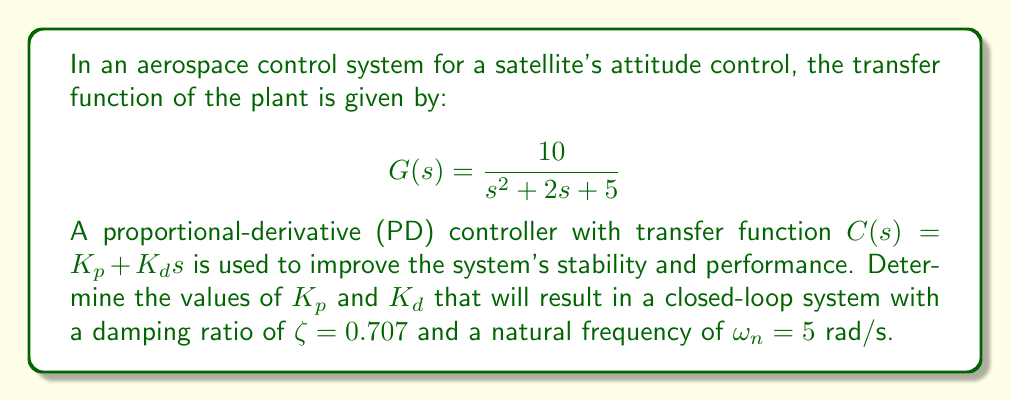What is the answer to this math problem? To solve this problem, we'll follow these steps:

1) The closed-loop transfer function of the system is:

   $$T(s) = \frac{C(s)G(s)}{1 + C(s)G(s)} = \frac{10(K_p + K_d s)}{s^2 + 2s + 5 + 10(K_p + K_d s)}$$

2) The denominator of this transfer function should match the standard second-order form:

   $$s^2 + 2\zeta\omega_n s + \omega_n^2$$

3) Expanding the denominator of our closed-loop transfer function:

   $$s^2 + (2 + 10K_d)s + (5 + 10K_p)$$

4) Equating coefficients with the standard form:

   $$2 + 10K_d = 2\zeta\omega_n = 2(0.707)(5) = 7.07$$
   $$5 + 10K_p = \omega_n^2 = 5^2 = 25$$

5) Solving these equations:

   $$10K_d = 7.07 - 2 = 5.07$$
   $$K_d = 0.507$$

   $$10K_p = 25 - 5 = 20$$
   $$K_p = 2$$

Therefore, the required controller gains are $K_p = 2$ and $K_d = 0.507$.
Answer: $K_p = 2$, $K_d = 0.507$ 